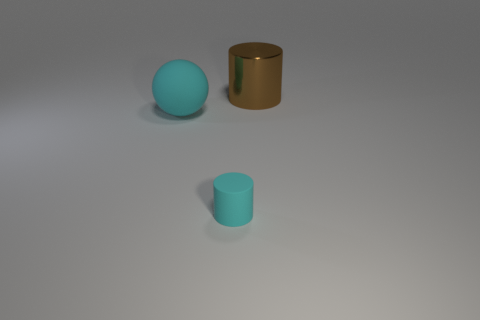Add 3 metallic things. How many objects exist? 6 Subtract all spheres. How many objects are left? 2 Subtract all big purple metallic cubes. Subtract all large brown things. How many objects are left? 2 Add 3 brown metallic things. How many brown metallic things are left? 4 Add 2 shiny balls. How many shiny balls exist? 2 Subtract 0 blue cylinders. How many objects are left? 3 